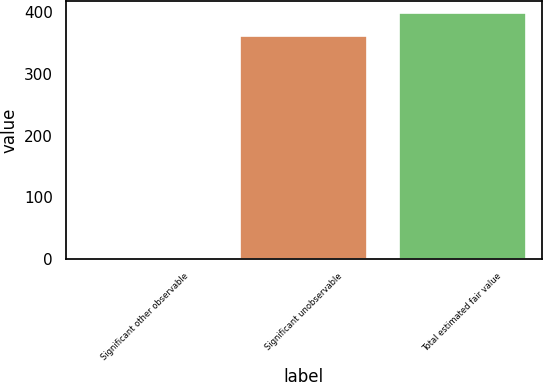Convert chart to OTSL. <chart><loc_0><loc_0><loc_500><loc_500><bar_chart><fcel>Significant other observable<fcel>Significant unobservable<fcel>Total estimated fair value<nl><fcel>1<fcel>362<fcel>398.2<nl></chart> 